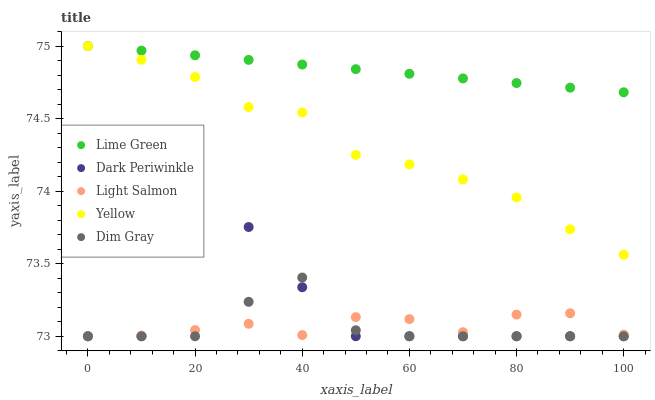Does Dim Gray have the minimum area under the curve?
Answer yes or no. Yes. Does Lime Green have the maximum area under the curve?
Answer yes or no. Yes. Does Lime Green have the minimum area under the curve?
Answer yes or no. No. Does Dim Gray have the maximum area under the curve?
Answer yes or no. No. Is Lime Green the smoothest?
Answer yes or no. Yes. Is Dark Periwinkle the roughest?
Answer yes or no. Yes. Is Dim Gray the smoothest?
Answer yes or no. No. Is Dim Gray the roughest?
Answer yes or no. No. Does Light Salmon have the lowest value?
Answer yes or no. Yes. Does Lime Green have the lowest value?
Answer yes or no. No. Does Yellow have the highest value?
Answer yes or no. Yes. Does Dim Gray have the highest value?
Answer yes or no. No. Is Dim Gray less than Lime Green?
Answer yes or no. Yes. Is Lime Green greater than Light Salmon?
Answer yes or no. Yes. Does Light Salmon intersect Dark Periwinkle?
Answer yes or no. Yes. Is Light Salmon less than Dark Periwinkle?
Answer yes or no. No. Is Light Salmon greater than Dark Periwinkle?
Answer yes or no. No. Does Dim Gray intersect Lime Green?
Answer yes or no. No. 